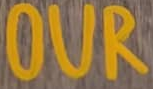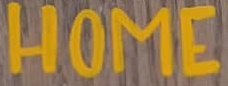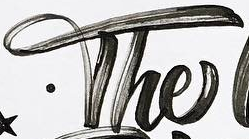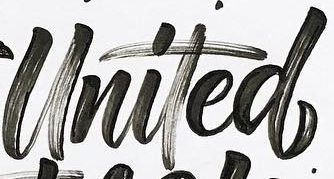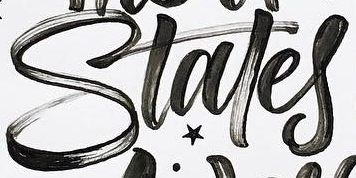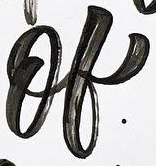Read the text from these images in sequence, separated by a semicolon. OUR; HOME; The; United; Stales; of 